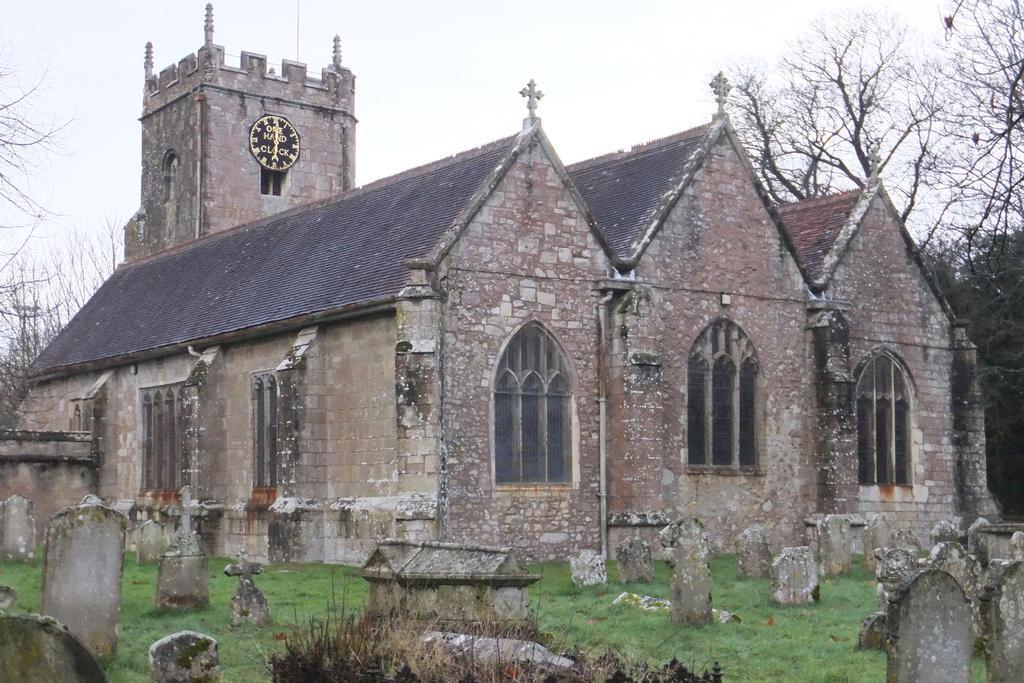Please provide a concise description of this image. In this image I can see in the middle there are houses. At the bottom there are graveyards. On the right side there is the tree, at the top it is the sky. 